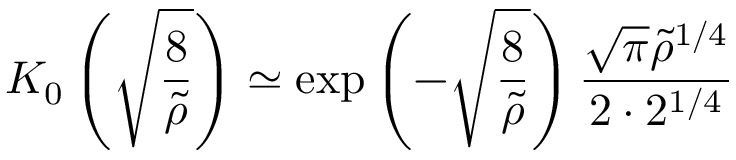Convert formula to latex. <formula><loc_0><loc_0><loc_500><loc_500>K _ { 0 } \left ( \sqrt { \frac { 8 } { \tilde { \rho } } } \right ) \simeq \exp \left ( - \sqrt { \frac { 8 } { \tilde { \rho } } } \right ) \frac { \sqrt { \pi } \tilde { \rho } ^ { 1 / 4 } } { 2 \cdot 2 ^ { 1 / 4 } }</formula> 